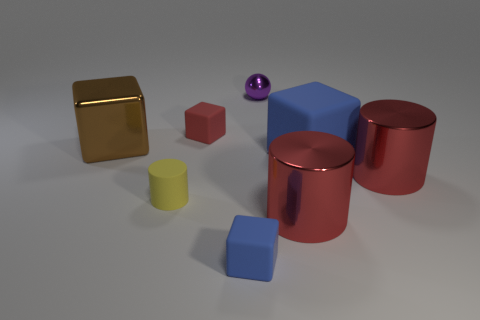Add 1 large cyan metal blocks. How many objects exist? 9 Subtract all spheres. How many objects are left? 7 Subtract 0 cyan cylinders. How many objects are left? 8 Subtract all large matte cylinders. Subtract all small purple spheres. How many objects are left? 7 Add 4 big blue cubes. How many big blue cubes are left? 5 Add 1 green metallic things. How many green metallic things exist? 1 